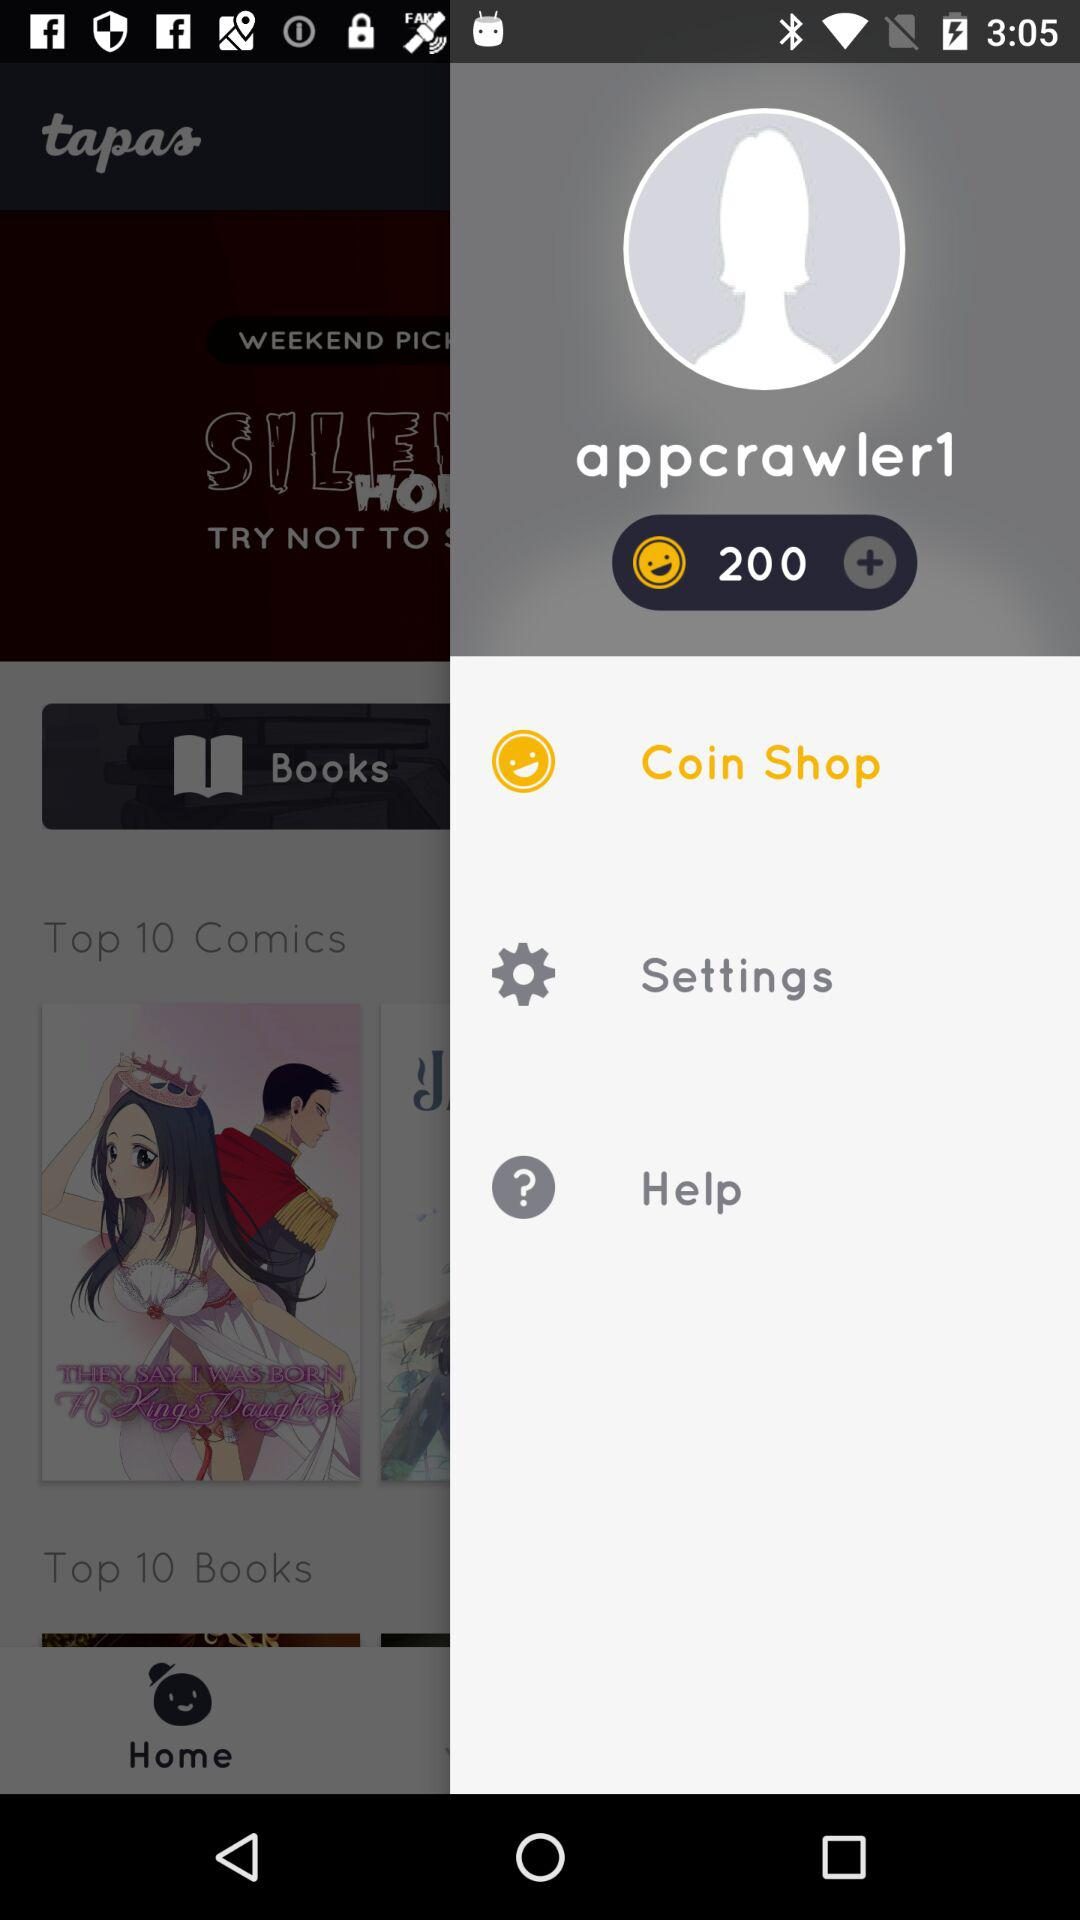How many coins are in the balance? There are 200 coins in the balance. 